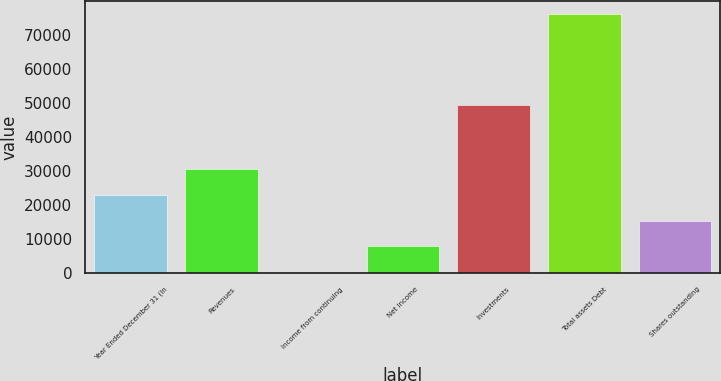<chart> <loc_0><loc_0><loc_500><loc_500><bar_chart><fcel>Year Ended December 31 (In<fcel>Revenues<fcel>Income from continuing<fcel>Net income<fcel>Investments<fcel>Total assets Debt<fcel>Shares outstanding<nl><fcel>22990.7<fcel>30567.6<fcel>260<fcel>7836.9<fcel>49400<fcel>76029<fcel>15413.8<nl></chart> 